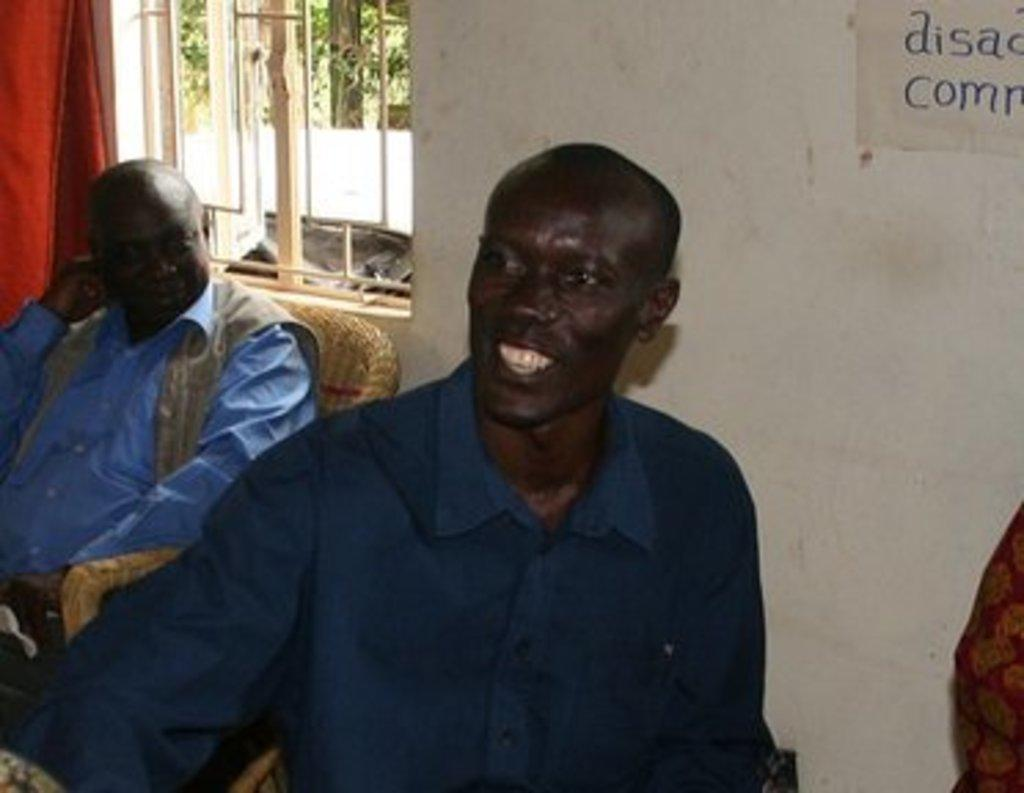What are the people in the image doing? The people in the image are sitting on chairs. What can be seen in the background of the image? There is a wall in the background of the image. What feature is present on the wall? There is a window in the wall. What is associated with the window? There is a curtain associated with the window. What is visible in the top right corner of the image? There is text visible in the top right corner of the image. What type of rice is being cooked in the image? There is no rice present in the image. How many bats are hanging from the curtain in the image? There are no bats present in the image. 